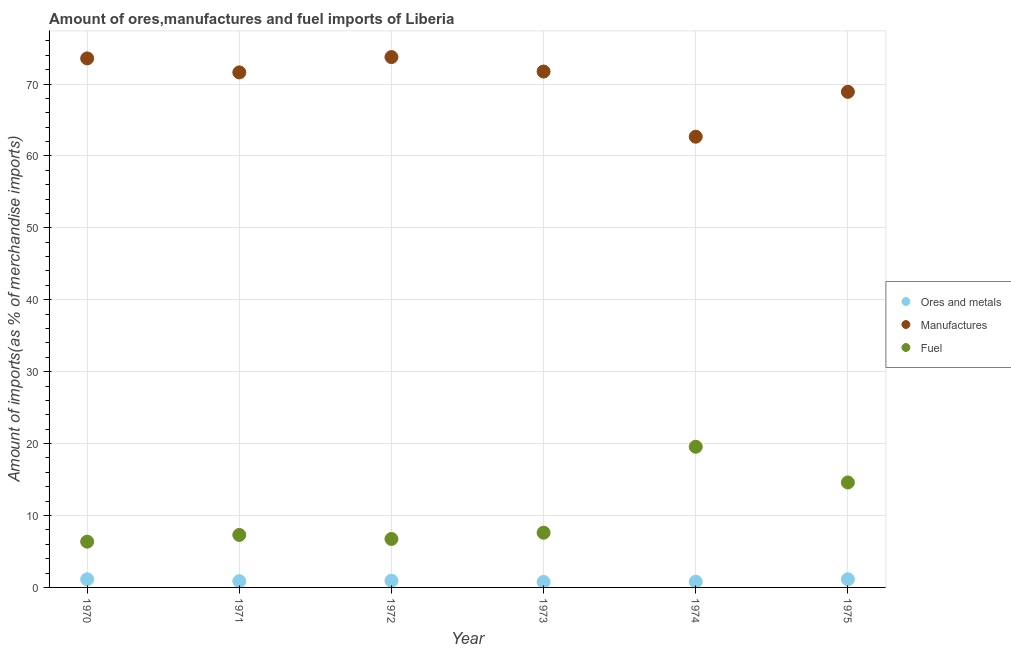What is the percentage of manufactures imports in 1975?
Provide a short and direct response. 68.91. Across all years, what is the maximum percentage of fuel imports?
Provide a succinct answer. 19.56. Across all years, what is the minimum percentage of manufactures imports?
Offer a very short reply. 62.67. In which year was the percentage of manufactures imports maximum?
Make the answer very short. 1972. In which year was the percentage of ores and metals imports minimum?
Make the answer very short. 1973. What is the total percentage of fuel imports in the graph?
Keep it short and to the point. 62.16. What is the difference between the percentage of fuel imports in 1971 and that in 1975?
Your answer should be compact. -7.3. What is the difference between the percentage of manufactures imports in 1974 and the percentage of ores and metals imports in 1970?
Your answer should be very brief. 61.54. What is the average percentage of ores and metals imports per year?
Your answer should be very brief. 0.94. In the year 1972, what is the difference between the percentage of ores and metals imports and percentage of fuel imports?
Offer a terse response. -5.81. What is the ratio of the percentage of manufactures imports in 1972 to that in 1975?
Give a very brief answer. 1.07. What is the difference between the highest and the second highest percentage of manufactures imports?
Offer a very short reply. 0.19. What is the difference between the highest and the lowest percentage of fuel imports?
Your answer should be compact. 13.19. In how many years, is the percentage of fuel imports greater than the average percentage of fuel imports taken over all years?
Provide a succinct answer. 2. Is the percentage of ores and metals imports strictly greater than the percentage of manufactures imports over the years?
Ensure brevity in your answer.  No. Is the percentage of fuel imports strictly less than the percentage of manufactures imports over the years?
Keep it short and to the point. Yes. How many dotlines are there?
Keep it short and to the point. 3. What is the difference between two consecutive major ticks on the Y-axis?
Give a very brief answer. 10. Does the graph contain any zero values?
Offer a terse response. No. Where does the legend appear in the graph?
Your response must be concise. Center right. How many legend labels are there?
Your response must be concise. 3. What is the title of the graph?
Offer a very short reply. Amount of ores,manufactures and fuel imports of Liberia. What is the label or title of the X-axis?
Ensure brevity in your answer.  Year. What is the label or title of the Y-axis?
Your response must be concise. Amount of imports(as % of merchandise imports). What is the Amount of imports(as % of merchandise imports) of Ores and metals in 1970?
Your response must be concise. 1.13. What is the Amount of imports(as % of merchandise imports) of Manufactures in 1970?
Provide a succinct answer. 73.56. What is the Amount of imports(as % of merchandise imports) in Fuel in 1970?
Offer a very short reply. 6.37. What is the Amount of imports(as % of merchandise imports) in Ores and metals in 1971?
Your response must be concise. 0.87. What is the Amount of imports(as % of merchandise imports) in Manufactures in 1971?
Ensure brevity in your answer.  71.62. What is the Amount of imports(as % of merchandise imports) of Fuel in 1971?
Provide a short and direct response. 7.3. What is the Amount of imports(as % of merchandise imports) of Ores and metals in 1972?
Your response must be concise. 0.93. What is the Amount of imports(as % of merchandise imports) of Manufactures in 1972?
Your answer should be very brief. 73.75. What is the Amount of imports(as % of merchandise imports) in Fuel in 1972?
Ensure brevity in your answer.  6.74. What is the Amount of imports(as % of merchandise imports) in Ores and metals in 1973?
Your answer should be very brief. 0.76. What is the Amount of imports(as % of merchandise imports) in Manufactures in 1973?
Offer a terse response. 71.73. What is the Amount of imports(as % of merchandise imports) in Fuel in 1973?
Ensure brevity in your answer.  7.61. What is the Amount of imports(as % of merchandise imports) in Ores and metals in 1974?
Provide a succinct answer. 0.8. What is the Amount of imports(as % of merchandise imports) of Manufactures in 1974?
Keep it short and to the point. 62.67. What is the Amount of imports(as % of merchandise imports) in Fuel in 1974?
Your response must be concise. 19.56. What is the Amount of imports(as % of merchandise imports) of Ores and metals in 1975?
Give a very brief answer. 1.13. What is the Amount of imports(as % of merchandise imports) of Manufactures in 1975?
Keep it short and to the point. 68.91. What is the Amount of imports(as % of merchandise imports) of Fuel in 1975?
Your response must be concise. 14.6. Across all years, what is the maximum Amount of imports(as % of merchandise imports) in Ores and metals?
Ensure brevity in your answer.  1.13. Across all years, what is the maximum Amount of imports(as % of merchandise imports) of Manufactures?
Keep it short and to the point. 73.75. Across all years, what is the maximum Amount of imports(as % of merchandise imports) in Fuel?
Offer a terse response. 19.56. Across all years, what is the minimum Amount of imports(as % of merchandise imports) in Ores and metals?
Your response must be concise. 0.76. Across all years, what is the minimum Amount of imports(as % of merchandise imports) of Manufactures?
Your answer should be compact. 62.67. Across all years, what is the minimum Amount of imports(as % of merchandise imports) of Fuel?
Your answer should be compact. 6.37. What is the total Amount of imports(as % of merchandise imports) in Ores and metals in the graph?
Ensure brevity in your answer.  5.62. What is the total Amount of imports(as % of merchandise imports) in Manufactures in the graph?
Your response must be concise. 422.24. What is the total Amount of imports(as % of merchandise imports) of Fuel in the graph?
Ensure brevity in your answer.  62.16. What is the difference between the Amount of imports(as % of merchandise imports) in Ores and metals in 1970 and that in 1971?
Provide a short and direct response. 0.26. What is the difference between the Amount of imports(as % of merchandise imports) of Manufactures in 1970 and that in 1971?
Offer a terse response. 1.94. What is the difference between the Amount of imports(as % of merchandise imports) of Fuel in 1970 and that in 1971?
Your response must be concise. -0.93. What is the difference between the Amount of imports(as % of merchandise imports) of Ores and metals in 1970 and that in 1972?
Your answer should be compact. 0.2. What is the difference between the Amount of imports(as % of merchandise imports) in Manufactures in 1970 and that in 1972?
Provide a succinct answer. -0.19. What is the difference between the Amount of imports(as % of merchandise imports) in Fuel in 1970 and that in 1972?
Give a very brief answer. -0.37. What is the difference between the Amount of imports(as % of merchandise imports) of Ores and metals in 1970 and that in 1973?
Ensure brevity in your answer.  0.37. What is the difference between the Amount of imports(as % of merchandise imports) in Manufactures in 1970 and that in 1973?
Offer a very short reply. 1.83. What is the difference between the Amount of imports(as % of merchandise imports) in Fuel in 1970 and that in 1973?
Your answer should be very brief. -1.24. What is the difference between the Amount of imports(as % of merchandise imports) of Ores and metals in 1970 and that in 1974?
Your response must be concise. 0.33. What is the difference between the Amount of imports(as % of merchandise imports) in Manufactures in 1970 and that in 1974?
Offer a very short reply. 10.89. What is the difference between the Amount of imports(as % of merchandise imports) of Fuel in 1970 and that in 1974?
Your response must be concise. -13.19. What is the difference between the Amount of imports(as % of merchandise imports) of Ores and metals in 1970 and that in 1975?
Offer a very short reply. -0. What is the difference between the Amount of imports(as % of merchandise imports) in Manufactures in 1970 and that in 1975?
Offer a very short reply. 4.65. What is the difference between the Amount of imports(as % of merchandise imports) in Fuel in 1970 and that in 1975?
Your response must be concise. -8.23. What is the difference between the Amount of imports(as % of merchandise imports) in Ores and metals in 1971 and that in 1972?
Keep it short and to the point. -0.06. What is the difference between the Amount of imports(as % of merchandise imports) of Manufactures in 1971 and that in 1972?
Offer a terse response. -2.13. What is the difference between the Amount of imports(as % of merchandise imports) of Fuel in 1971 and that in 1972?
Your response must be concise. 0.56. What is the difference between the Amount of imports(as % of merchandise imports) of Ores and metals in 1971 and that in 1973?
Your answer should be very brief. 0.11. What is the difference between the Amount of imports(as % of merchandise imports) of Manufactures in 1971 and that in 1973?
Provide a short and direct response. -0.12. What is the difference between the Amount of imports(as % of merchandise imports) in Fuel in 1971 and that in 1973?
Make the answer very short. -0.31. What is the difference between the Amount of imports(as % of merchandise imports) of Ores and metals in 1971 and that in 1974?
Provide a succinct answer. 0.07. What is the difference between the Amount of imports(as % of merchandise imports) of Manufactures in 1971 and that in 1974?
Your answer should be very brief. 8.94. What is the difference between the Amount of imports(as % of merchandise imports) of Fuel in 1971 and that in 1974?
Give a very brief answer. -12.26. What is the difference between the Amount of imports(as % of merchandise imports) in Ores and metals in 1971 and that in 1975?
Ensure brevity in your answer.  -0.26. What is the difference between the Amount of imports(as % of merchandise imports) of Manufactures in 1971 and that in 1975?
Provide a short and direct response. 2.7. What is the difference between the Amount of imports(as % of merchandise imports) in Fuel in 1971 and that in 1975?
Ensure brevity in your answer.  -7.3. What is the difference between the Amount of imports(as % of merchandise imports) in Ores and metals in 1972 and that in 1973?
Your answer should be very brief. 0.17. What is the difference between the Amount of imports(as % of merchandise imports) of Manufactures in 1972 and that in 1973?
Your answer should be compact. 2.01. What is the difference between the Amount of imports(as % of merchandise imports) in Fuel in 1972 and that in 1973?
Make the answer very short. -0.87. What is the difference between the Amount of imports(as % of merchandise imports) in Ores and metals in 1972 and that in 1974?
Provide a short and direct response. 0.13. What is the difference between the Amount of imports(as % of merchandise imports) of Manufactures in 1972 and that in 1974?
Your answer should be compact. 11.07. What is the difference between the Amount of imports(as % of merchandise imports) of Fuel in 1972 and that in 1974?
Provide a short and direct response. -12.82. What is the difference between the Amount of imports(as % of merchandise imports) of Ores and metals in 1972 and that in 1975?
Your answer should be very brief. -0.2. What is the difference between the Amount of imports(as % of merchandise imports) in Manufactures in 1972 and that in 1975?
Keep it short and to the point. 4.83. What is the difference between the Amount of imports(as % of merchandise imports) of Fuel in 1972 and that in 1975?
Your response must be concise. -7.86. What is the difference between the Amount of imports(as % of merchandise imports) in Ores and metals in 1973 and that in 1974?
Keep it short and to the point. -0.04. What is the difference between the Amount of imports(as % of merchandise imports) in Manufactures in 1973 and that in 1974?
Offer a very short reply. 9.06. What is the difference between the Amount of imports(as % of merchandise imports) in Fuel in 1973 and that in 1974?
Keep it short and to the point. -11.95. What is the difference between the Amount of imports(as % of merchandise imports) in Ores and metals in 1973 and that in 1975?
Offer a very short reply. -0.37. What is the difference between the Amount of imports(as % of merchandise imports) in Manufactures in 1973 and that in 1975?
Your response must be concise. 2.82. What is the difference between the Amount of imports(as % of merchandise imports) in Fuel in 1973 and that in 1975?
Offer a terse response. -6.99. What is the difference between the Amount of imports(as % of merchandise imports) in Ores and metals in 1974 and that in 1975?
Your answer should be compact. -0.33. What is the difference between the Amount of imports(as % of merchandise imports) in Manufactures in 1974 and that in 1975?
Provide a succinct answer. -6.24. What is the difference between the Amount of imports(as % of merchandise imports) of Fuel in 1974 and that in 1975?
Your answer should be compact. 4.96. What is the difference between the Amount of imports(as % of merchandise imports) in Ores and metals in 1970 and the Amount of imports(as % of merchandise imports) in Manufactures in 1971?
Your answer should be very brief. -70.49. What is the difference between the Amount of imports(as % of merchandise imports) in Ores and metals in 1970 and the Amount of imports(as % of merchandise imports) in Fuel in 1971?
Ensure brevity in your answer.  -6.17. What is the difference between the Amount of imports(as % of merchandise imports) of Manufactures in 1970 and the Amount of imports(as % of merchandise imports) of Fuel in 1971?
Provide a short and direct response. 66.26. What is the difference between the Amount of imports(as % of merchandise imports) of Ores and metals in 1970 and the Amount of imports(as % of merchandise imports) of Manufactures in 1972?
Provide a short and direct response. -72.62. What is the difference between the Amount of imports(as % of merchandise imports) of Ores and metals in 1970 and the Amount of imports(as % of merchandise imports) of Fuel in 1972?
Offer a very short reply. -5.61. What is the difference between the Amount of imports(as % of merchandise imports) of Manufactures in 1970 and the Amount of imports(as % of merchandise imports) of Fuel in 1972?
Your answer should be very brief. 66.82. What is the difference between the Amount of imports(as % of merchandise imports) in Ores and metals in 1970 and the Amount of imports(as % of merchandise imports) in Manufactures in 1973?
Provide a succinct answer. -70.6. What is the difference between the Amount of imports(as % of merchandise imports) of Ores and metals in 1970 and the Amount of imports(as % of merchandise imports) of Fuel in 1973?
Provide a short and direct response. -6.48. What is the difference between the Amount of imports(as % of merchandise imports) in Manufactures in 1970 and the Amount of imports(as % of merchandise imports) in Fuel in 1973?
Give a very brief answer. 65.95. What is the difference between the Amount of imports(as % of merchandise imports) in Ores and metals in 1970 and the Amount of imports(as % of merchandise imports) in Manufactures in 1974?
Offer a very short reply. -61.54. What is the difference between the Amount of imports(as % of merchandise imports) of Ores and metals in 1970 and the Amount of imports(as % of merchandise imports) of Fuel in 1974?
Keep it short and to the point. -18.43. What is the difference between the Amount of imports(as % of merchandise imports) in Manufactures in 1970 and the Amount of imports(as % of merchandise imports) in Fuel in 1974?
Offer a terse response. 54. What is the difference between the Amount of imports(as % of merchandise imports) of Ores and metals in 1970 and the Amount of imports(as % of merchandise imports) of Manufactures in 1975?
Ensure brevity in your answer.  -67.78. What is the difference between the Amount of imports(as % of merchandise imports) in Ores and metals in 1970 and the Amount of imports(as % of merchandise imports) in Fuel in 1975?
Keep it short and to the point. -13.47. What is the difference between the Amount of imports(as % of merchandise imports) in Manufactures in 1970 and the Amount of imports(as % of merchandise imports) in Fuel in 1975?
Ensure brevity in your answer.  58.96. What is the difference between the Amount of imports(as % of merchandise imports) in Ores and metals in 1971 and the Amount of imports(as % of merchandise imports) in Manufactures in 1972?
Your answer should be very brief. -72.87. What is the difference between the Amount of imports(as % of merchandise imports) of Ores and metals in 1971 and the Amount of imports(as % of merchandise imports) of Fuel in 1972?
Offer a terse response. -5.87. What is the difference between the Amount of imports(as % of merchandise imports) in Manufactures in 1971 and the Amount of imports(as % of merchandise imports) in Fuel in 1972?
Give a very brief answer. 64.88. What is the difference between the Amount of imports(as % of merchandise imports) of Ores and metals in 1971 and the Amount of imports(as % of merchandise imports) of Manufactures in 1973?
Give a very brief answer. -70.86. What is the difference between the Amount of imports(as % of merchandise imports) in Ores and metals in 1971 and the Amount of imports(as % of merchandise imports) in Fuel in 1973?
Make the answer very short. -6.74. What is the difference between the Amount of imports(as % of merchandise imports) of Manufactures in 1971 and the Amount of imports(as % of merchandise imports) of Fuel in 1973?
Give a very brief answer. 64.01. What is the difference between the Amount of imports(as % of merchandise imports) of Ores and metals in 1971 and the Amount of imports(as % of merchandise imports) of Manufactures in 1974?
Provide a short and direct response. -61.8. What is the difference between the Amount of imports(as % of merchandise imports) in Ores and metals in 1971 and the Amount of imports(as % of merchandise imports) in Fuel in 1974?
Keep it short and to the point. -18.69. What is the difference between the Amount of imports(as % of merchandise imports) of Manufactures in 1971 and the Amount of imports(as % of merchandise imports) of Fuel in 1974?
Give a very brief answer. 52.06. What is the difference between the Amount of imports(as % of merchandise imports) in Ores and metals in 1971 and the Amount of imports(as % of merchandise imports) in Manufactures in 1975?
Make the answer very short. -68.04. What is the difference between the Amount of imports(as % of merchandise imports) of Ores and metals in 1971 and the Amount of imports(as % of merchandise imports) of Fuel in 1975?
Give a very brief answer. -13.73. What is the difference between the Amount of imports(as % of merchandise imports) of Manufactures in 1971 and the Amount of imports(as % of merchandise imports) of Fuel in 1975?
Provide a succinct answer. 57.02. What is the difference between the Amount of imports(as % of merchandise imports) in Ores and metals in 1972 and the Amount of imports(as % of merchandise imports) in Manufactures in 1973?
Your answer should be very brief. -70.8. What is the difference between the Amount of imports(as % of merchandise imports) of Ores and metals in 1972 and the Amount of imports(as % of merchandise imports) of Fuel in 1973?
Provide a succinct answer. -6.68. What is the difference between the Amount of imports(as % of merchandise imports) of Manufactures in 1972 and the Amount of imports(as % of merchandise imports) of Fuel in 1973?
Provide a succinct answer. 66.14. What is the difference between the Amount of imports(as % of merchandise imports) of Ores and metals in 1972 and the Amount of imports(as % of merchandise imports) of Manufactures in 1974?
Your response must be concise. -61.74. What is the difference between the Amount of imports(as % of merchandise imports) of Ores and metals in 1972 and the Amount of imports(as % of merchandise imports) of Fuel in 1974?
Your answer should be compact. -18.63. What is the difference between the Amount of imports(as % of merchandise imports) of Manufactures in 1972 and the Amount of imports(as % of merchandise imports) of Fuel in 1974?
Make the answer very short. 54.19. What is the difference between the Amount of imports(as % of merchandise imports) of Ores and metals in 1972 and the Amount of imports(as % of merchandise imports) of Manufactures in 1975?
Your answer should be very brief. -67.99. What is the difference between the Amount of imports(as % of merchandise imports) of Ores and metals in 1972 and the Amount of imports(as % of merchandise imports) of Fuel in 1975?
Offer a terse response. -13.67. What is the difference between the Amount of imports(as % of merchandise imports) of Manufactures in 1972 and the Amount of imports(as % of merchandise imports) of Fuel in 1975?
Offer a terse response. 59.15. What is the difference between the Amount of imports(as % of merchandise imports) in Ores and metals in 1973 and the Amount of imports(as % of merchandise imports) in Manufactures in 1974?
Provide a succinct answer. -61.91. What is the difference between the Amount of imports(as % of merchandise imports) of Ores and metals in 1973 and the Amount of imports(as % of merchandise imports) of Fuel in 1974?
Offer a very short reply. -18.8. What is the difference between the Amount of imports(as % of merchandise imports) in Manufactures in 1973 and the Amount of imports(as % of merchandise imports) in Fuel in 1974?
Offer a very short reply. 52.17. What is the difference between the Amount of imports(as % of merchandise imports) of Ores and metals in 1973 and the Amount of imports(as % of merchandise imports) of Manufactures in 1975?
Your response must be concise. -68.15. What is the difference between the Amount of imports(as % of merchandise imports) in Ores and metals in 1973 and the Amount of imports(as % of merchandise imports) in Fuel in 1975?
Give a very brief answer. -13.83. What is the difference between the Amount of imports(as % of merchandise imports) of Manufactures in 1973 and the Amount of imports(as % of merchandise imports) of Fuel in 1975?
Provide a succinct answer. 57.14. What is the difference between the Amount of imports(as % of merchandise imports) in Ores and metals in 1974 and the Amount of imports(as % of merchandise imports) in Manufactures in 1975?
Keep it short and to the point. -68.12. What is the difference between the Amount of imports(as % of merchandise imports) in Ores and metals in 1974 and the Amount of imports(as % of merchandise imports) in Fuel in 1975?
Offer a terse response. -13.8. What is the difference between the Amount of imports(as % of merchandise imports) of Manufactures in 1974 and the Amount of imports(as % of merchandise imports) of Fuel in 1975?
Give a very brief answer. 48.08. What is the average Amount of imports(as % of merchandise imports) in Ores and metals per year?
Keep it short and to the point. 0.94. What is the average Amount of imports(as % of merchandise imports) of Manufactures per year?
Keep it short and to the point. 70.37. What is the average Amount of imports(as % of merchandise imports) of Fuel per year?
Offer a terse response. 10.36. In the year 1970, what is the difference between the Amount of imports(as % of merchandise imports) of Ores and metals and Amount of imports(as % of merchandise imports) of Manufactures?
Ensure brevity in your answer.  -72.43. In the year 1970, what is the difference between the Amount of imports(as % of merchandise imports) of Ores and metals and Amount of imports(as % of merchandise imports) of Fuel?
Your answer should be very brief. -5.24. In the year 1970, what is the difference between the Amount of imports(as % of merchandise imports) of Manufactures and Amount of imports(as % of merchandise imports) of Fuel?
Your answer should be compact. 67.19. In the year 1971, what is the difference between the Amount of imports(as % of merchandise imports) of Ores and metals and Amount of imports(as % of merchandise imports) of Manufactures?
Give a very brief answer. -70.74. In the year 1971, what is the difference between the Amount of imports(as % of merchandise imports) in Ores and metals and Amount of imports(as % of merchandise imports) in Fuel?
Keep it short and to the point. -6.43. In the year 1971, what is the difference between the Amount of imports(as % of merchandise imports) in Manufactures and Amount of imports(as % of merchandise imports) in Fuel?
Your answer should be compact. 64.32. In the year 1972, what is the difference between the Amount of imports(as % of merchandise imports) in Ores and metals and Amount of imports(as % of merchandise imports) in Manufactures?
Ensure brevity in your answer.  -72.82. In the year 1972, what is the difference between the Amount of imports(as % of merchandise imports) in Ores and metals and Amount of imports(as % of merchandise imports) in Fuel?
Your response must be concise. -5.81. In the year 1972, what is the difference between the Amount of imports(as % of merchandise imports) of Manufactures and Amount of imports(as % of merchandise imports) of Fuel?
Keep it short and to the point. 67.01. In the year 1973, what is the difference between the Amount of imports(as % of merchandise imports) in Ores and metals and Amount of imports(as % of merchandise imports) in Manufactures?
Offer a very short reply. -70.97. In the year 1973, what is the difference between the Amount of imports(as % of merchandise imports) in Ores and metals and Amount of imports(as % of merchandise imports) in Fuel?
Provide a succinct answer. -6.85. In the year 1973, what is the difference between the Amount of imports(as % of merchandise imports) of Manufactures and Amount of imports(as % of merchandise imports) of Fuel?
Keep it short and to the point. 64.12. In the year 1974, what is the difference between the Amount of imports(as % of merchandise imports) in Ores and metals and Amount of imports(as % of merchandise imports) in Manufactures?
Give a very brief answer. -61.87. In the year 1974, what is the difference between the Amount of imports(as % of merchandise imports) in Ores and metals and Amount of imports(as % of merchandise imports) in Fuel?
Offer a very short reply. -18.76. In the year 1974, what is the difference between the Amount of imports(as % of merchandise imports) of Manufactures and Amount of imports(as % of merchandise imports) of Fuel?
Offer a very short reply. 43.11. In the year 1975, what is the difference between the Amount of imports(as % of merchandise imports) of Ores and metals and Amount of imports(as % of merchandise imports) of Manufactures?
Make the answer very short. -67.78. In the year 1975, what is the difference between the Amount of imports(as % of merchandise imports) of Ores and metals and Amount of imports(as % of merchandise imports) of Fuel?
Provide a succinct answer. -13.46. In the year 1975, what is the difference between the Amount of imports(as % of merchandise imports) in Manufactures and Amount of imports(as % of merchandise imports) in Fuel?
Offer a very short reply. 54.32. What is the ratio of the Amount of imports(as % of merchandise imports) of Ores and metals in 1970 to that in 1971?
Provide a succinct answer. 1.3. What is the ratio of the Amount of imports(as % of merchandise imports) in Manufactures in 1970 to that in 1971?
Make the answer very short. 1.03. What is the ratio of the Amount of imports(as % of merchandise imports) in Fuel in 1970 to that in 1971?
Offer a terse response. 0.87. What is the ratio of the Amount of imports(as % of merchandise imports) in Ores and metals in 1970 to that in 1972?
Provide a short and direct response. 1.22. What is the ratio of the Amount of imports(as % of merchandise imports) in Fuel in 1970 to that in 1972?
Keep it short and to the point. 0.94. What is the ratio of the Amount of imports(as % of merchandise imports) of Ores and metals in 1970 to that in 1973?
Your answer should be very brief. 1.48. What is the ratio of the Amount of imports(as % of merchandise imports) of Manufactures in 1970 to that in 1973?
Provide a short and direct response. 1.03. What is the ratio of the Amount of imports(as % of merchandise imports) of Fuel in 1970 to that in 1973?
Give a very brief answer. 0.84. What is the ratio of the Amount of imports(as % of merchandise imports) of Ores and metals in 1970 to that in 1974?
Keep it short and to the point. 1.41. What is the ratio of the Amount of imports(as % of merchandise imports) of Manufactures in 1970 to that in 1974?
Keep it short and to the point. 1.17. What is the ratio of the Amount of imports(as % of merchandise imports) of Fuel in 1970 to that in 1974?
Offer a very short reply. 0.33. What is the ratio of the Amount of imports(as % of merchandise imports) in Ores and metals in 1970 to that in 1975?
Your answer should be very brief. 1. What is the ratio of the Amount of imports(as % of merchandise imports) in Manufactures in 1970 to that in 1975?
Your response must be concise. 1.07. What is the ratio of the Amount of imports(as % of merchandise imports) in Fuel in 1970 to that in 1975?
Keep it short and to the point. 0.44. What is the ratio of the Amount of imports(as % of merchandise imports) of Ores and metals in 1971 to that in 1972?
Your answer should be compact. 0.94. What is the ratio of the Amount of imports(as % of merchandise imports) in Manufactures in 1971 to that in 1972?
Keep it short and to the point. 0.97. What is the ratio of the Amount of imports(as % of merchandise imports) in Fuel in 1971 to that in 1972?
Make the answer very short. 1.08. What is the ratio of the Amount of imports(as % of merchandise imports) of Ores and metals in 1971 to that in 1973?
Make the answer very short. 1.14. What is the ratio of the Amount of imports(as % of merchandise imports) in Manufactures in 1971 to that in 1973?
Keep it short and to the point. 1. What is the ratio of the Amount of imports(as % of merchandise imports) of Fuel in 1971 to that in 1973?
Offer a very short reply. 0.96. What is the ratio of the Amount of imports(as % of merchandise imports) of Ores and metals in 1971 to that in 1974?
Your answer should be compact. 1.09. What is the ratio of the Amount of imports(as % of merchandise imports) of Manufactures in 1971 to that in 1974?
Your answer should be very brief. 1.14. What is the ratio of the Amount of imports(as % of merchandise imports) in Fuel in 1971 to that in 1974?
Keep it short and to the point. 0.37. What is the ratio of the Amount of imports(as % of merchandise imports) in Ores and metals in 1971 to that in 1975?
Your response must be concise. 0.77. What is the ratio of the Amount of imports(as % of merchandise imports) in Manufactures in 1971 to that in 1975?
Make the answer very short. 1.04. What is the ratio of the Amount of imports(as % of merchandise imports) of Fuel in 1971 to that in 1975?
Keep it short and to the point. 0.5. What is the ratio of the Amount of imports(as % of merchandise imports) in Ores and metals in 1972 to that in 1973?
Keep it short and to the point. 1.22. What is the ratio of the Amount of imports(as % of merchandise imports) of Manufactures in 1972 to that in 1973?
Your answer should be compact. 1.03. What is the ratio of the Amount of imports(as % of merchandise imports) in Fuel in 1972 to that in 1973?
Keep it short and to the point. 0.89. What is the ratio of the Amount of imports(as % of merchandise imports) in Ores and metals in 1972 to that in 1974?
Offer a very short reply. 1.16. What is the ratio of the Amount of imports(as % of merchandise imports) in Manufactures in 1972 to that in 1974?
Keep it short and to the point. 1.18. What is the ratio of the Amount of imports(as % of merchandise imports) of Fuel in 1972 to that in 1974?
Keep it short and to the point. 0.34. What is the ratio of the Amount of imports(as % of merchandise imports) of Ores and metals in 1972 to that in 1975?
Provide a short and direct response. 0.82. What is the ratio of the Amount of imports(as % of merchandise imports) of Manufactures in 1972 to that in 1975?
Give a very brief answer. 1.07. What is the ratio of the Amount of imports(as % of merchandise imports) of Fuel in 1972 to that in 1975?
Make the answer very short. 0.46. What is the ratio of the Amount of imports(as % of merchandise imports) in Ores and metals in 1973 to that in 1974?
Ensure brevity in your answer.  0.95. What is the ratio of the Amount of imports(as % of merchandise imports) of Manufactures in 1973 to that in 1974?
Keep it short and to the point. 1.14. What is the ratio of the Amount of imports(as % of merchandise imports) of Fuel in 1973 to that in 1974?
Your answer should be very brief. 0.39. What is the ratio of the Amount of imports(as % of merchandise imports) of Ores and metals in 1973 to that in 1975?
Offer a terse response. 0.67. What is the ratio of the Amount of imports(as % of merchandise imports) in Manufactures in 1973 to that in 1975?
Provide a succinct answer. 1.04. What is the ratio of the Amount of imports(as % of merchandise imports) of Fuel in 1973 to that in 1975?
Ensure brevity in your answer.  0.52. What is the ratio of the Amount of imports(as % of merchandise imports) of Ores and metals in 1974 to that in 1975?
Provide a succinct answer. 0.7. What is the ratio of the Amount of imports(as % of merchandise imports) in Manufactures in 1974 to that in 1975?
Provide a succinct answer. 0.91. What is the ratio of the Amount of imports(as % of merchandise imports) in Fuel in 1974 to that in 1975?
Your answer should be very brief. 1.34. What is the difference between the highest and the second highest Amount of imports(as % of merchandise imports) in Ores and metals?
Offer a very short reply. 0. What is the difference between the highest and the second highest Amount of imports(as % of merchandise imports) of Manufactures?
Your answer should be compact. 0.19. What is the difference between the highest and the second highest Amount of imports(as % of merchandise imports) of Fuel?
Make the answer very short. 4.96. What is the difference between the highest and the lowest Amount of imports(as % of merchandise imports) in Ores and metals?
Offer a terse response. 0.37. What is the difference between the highest and the lowest Amount of imports(as % of merchandise imports) in Manufactures?
Give a very brief answer. 11.07. What is the difference between the highest and the lowest Amount of imports(as % of merchandise imports) in Fuel?
Give a very brief answer. 13.19. 